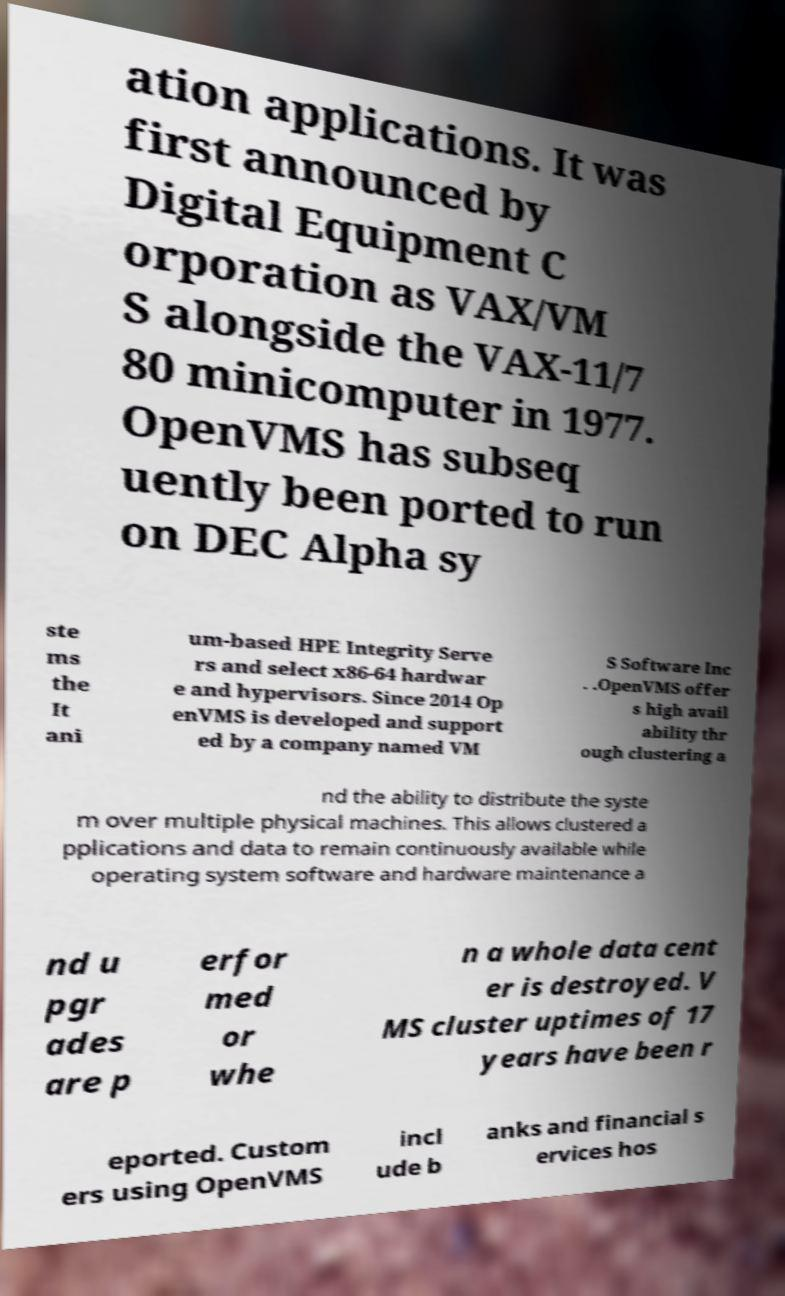There's text embedded in this image that I need extracted. Can you transcribe it verbatim? ation applications. It was first announced by Digital Equipment C orporation as VAX/VM S alongside the VAX-11/7 80 minicomputer in 1977. OpenVMS has subseq uently been ported to run on DEC Alpha sy ste ms the It ani um-based HPE Integrity Serve rs and select x86-64 hardwar e and hypervisors. Since 2014 Op enVMS is developed and support ed by a company named VM S Software Inc . .OpenVMS offer s high avail ability thr ough clustering a nd the ability to distribute the syste m over multiple physical machines. This allows clustered a pplications and data to remain continuously available while operating system software and hardware maintenance a nd u pgr ades are p erfor med or whe n a whole data cent er is destroyed. V MS cluster uptimes of 17 years have been r eported. Custom ers using OpenVMS incl ude b anks and financial s ervices hos 